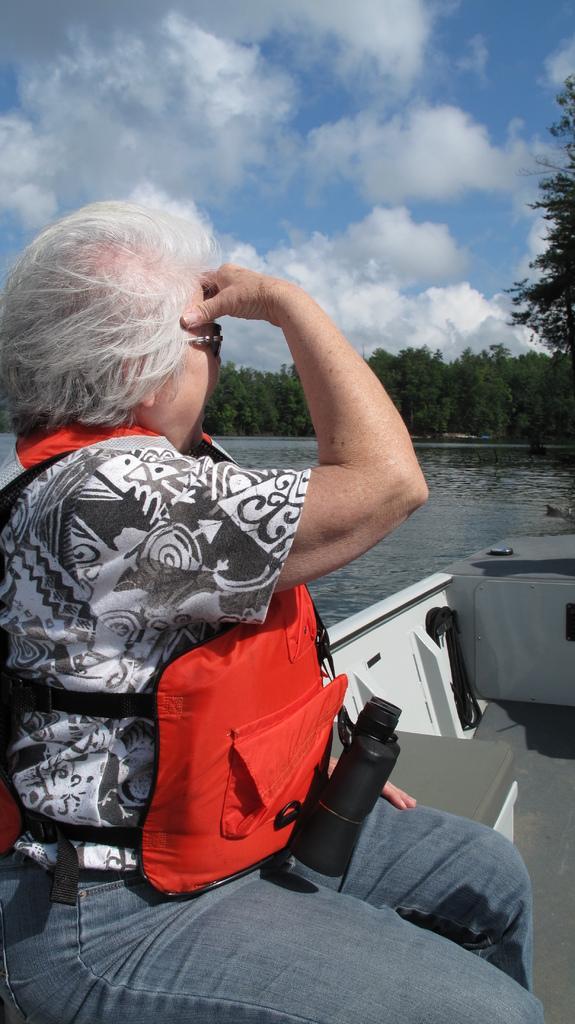Can you describe this image briefly? In this image, we can see a person wearing a jacket and glasses and wearing a binoculars and sitting on the boat and in the background, there are trees and there is water. At the top, there are clouds in the sky. 